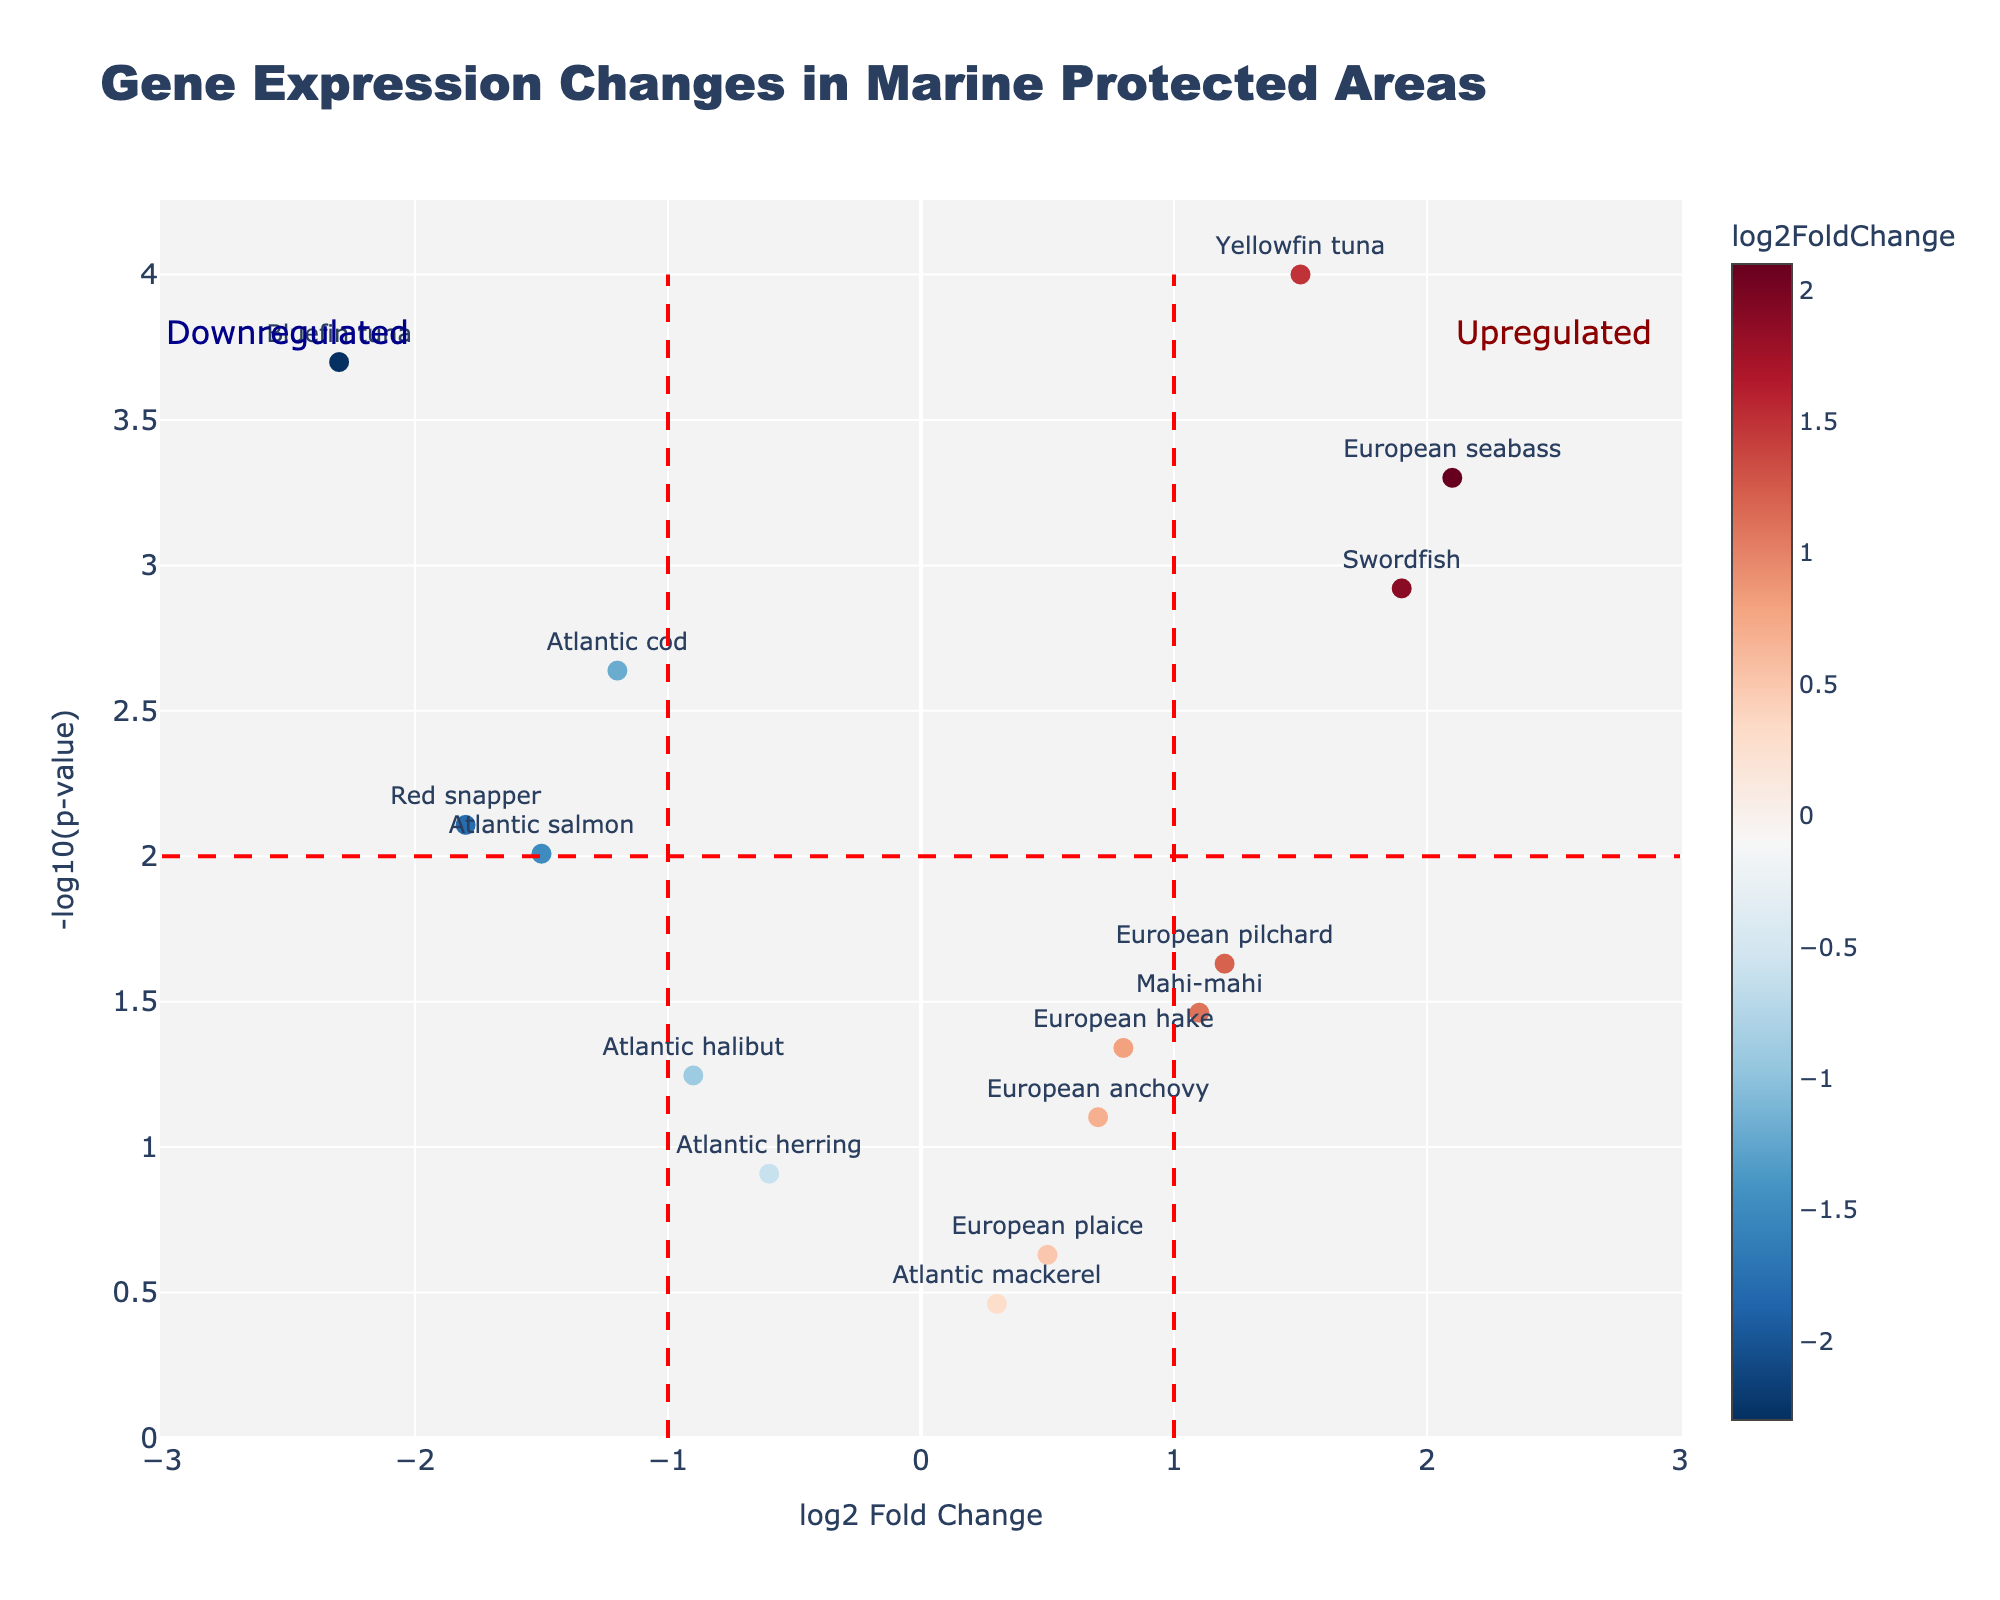Which gene has the highest -log10(p-value)? By inspecting the y-axis representing -log10(p-value), we identify the gene at the highest point on the plot. The gene "Yellowfin tuna" is at the apex of the plot.
Answer: Yellowfin tuna What is the title of the figure? The title of the figure is clearly displayed at the top center of the plot. It reads "Gene Expression Changes in Marine Protected Areas."
Answer: Gene Expression Changes in Marine Protected Areas Which gene shows the most substantial downregulation? To determine the most substantial downregulation, we look for the gene with the most negative log2FoldChange value on the x-axis. The gene "Bluefin tuna" has the farthest left position.
Answer: Bluefin tuna What is the color bar for? The color bar next to the plot indicates the log2FoldChange values, where different colors represent the degree of upregulation or downregulation of gene expression. This helps in visually differentiating the extent of changes across genes.
Answer: log2FoldChange values How many genes have upregulated expression changes with p-values less than 0.01? We look for points to the right of the significance line at x=1 and above the threshold in the y-axis representing -log10(0.01). The genes "Yellowfin tuna," "European seabass," and "Swordfish" satisfy these conditions.
Answer: 3 Which gene has both significant (-log10(p-value) > 2) and significantly upregulated (log2FoldChange > 1) expression? We search for genes in the upper right quadrant, above the -log10(p-value) > 2 line, and to the right of the log2FoldChange > 1 line. The gene "European seabass" meets these criteria.
Answer: European seabass Which gene has the smallest significant p-value? By identifying the highest point on the y-axis representing -log10(p-value), we find it is "Yellowfin tuna." To verify, you would convert -log10(0.0001) back to the original p-value.
Answer: Yellowfin tuna Do any genes show a non-significant log2FoldChange (>1) but with p-value > 0.05? We check for genes to the right of the significance line at x=1 but are below the threshold line on the y-axis at -log10(0.05). No genes fit this criterion in the plot.
Answer: No How does "European hake" compare in terms of upregulation to "European pilchard"? We compare their log2FoldChange values. "European hake" has a log2FoldChange of 0.8, while "European pilchard" has a higher value at 1.2, indicating that "European pilchard" is more upregulated.
Answer: European pilchard What annotation indicates where significantly upregulated genes are located? There is an annotation on the plot at the top right, labeled "Upregulated." This shows genes with log2FoldChange > 1 and -log10(p-value) > 2.
Answer: Upregulated 